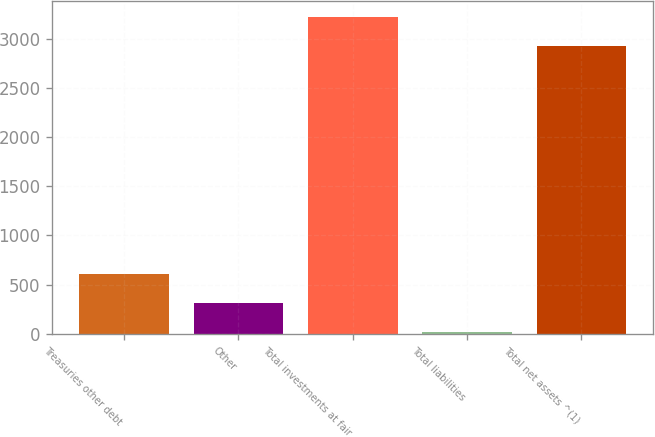Convert chart to OTSL. <chart><loc_0><loc_0><loc_500><loc_500><bar_chart><fcel>Treasuries other debt<fcel>Other<fcel>Total investments at fair<fcel>Total liabilities<fcel>Total net assets ^(1)<nl><fcel>606<fcel>313<fcel>3223<fcel>20<fcel>2930<nl></chart> 